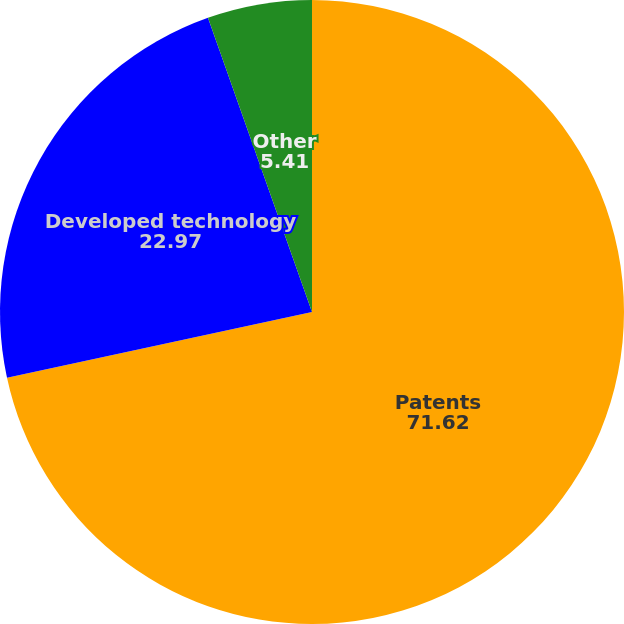Convert chart. <chart><loc_0><loc_0><loc_500><loc_500><pie_chart><fcel>Patents<fcel>Developed technology<fcel>Other<nl><fcel>71.62%<fcel>22.97%<fcel>5.41%<nl></chart> 